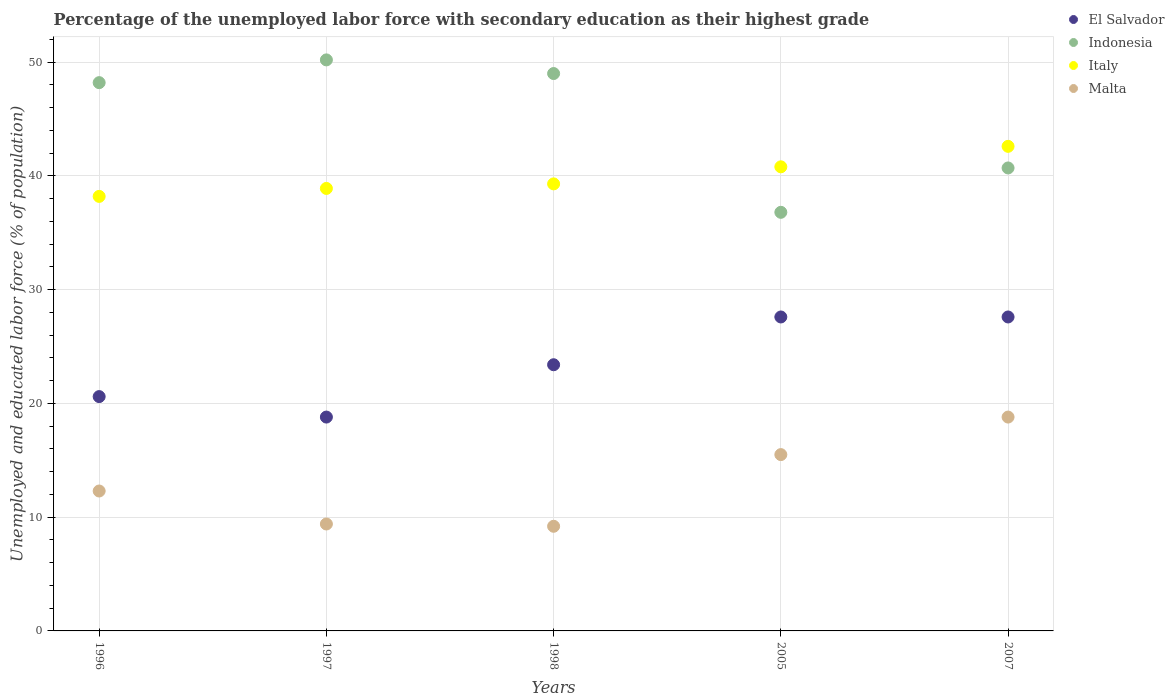How many different coloured dotlines are there?
Keep it short and to the point. 4. What is the percentage of the unemployed labor force with secondary education in Malta in 1998?
Offer a very short reply. 9.2. Across all years, what is the maximum percentage of the unemployed labor force with secondary education in Italy?
Make the answer very short. 42.6. Across all years, what is the minimum percentage of the unemployed labor force with secondary education in Indonesia?
Offer a very short reply. 36.8. In which year was the percentage of the unemployed labor force with secondary education in Malta maximum?
Give a very brief answer. 2007. What is the total percentage of the unemployed labor force with secondary education in El Salvador in the graph?
Offer a very short reply. 118. What is the difference between the percentage of the unemployed labor force with secondary education in Malta in 1996 and that in 1998?
Provide a short and direct response. 3.1. What is the difference between the percentage of the unemployed labor force with secondary education in El Salvador in 2005 and the percentage of the unemployed labor force with secondary education in Indonesia in 1996?
Keep it short and to the point. -20.6. What is the average percentage of the unemployed labor force with secondary education in Malta per year?
Keep it short and to the point. 13.04. In the year 2007, what is the difference between the percentage of the unemployed labor force with secondary education in Malta and percentage of the unemployed labor force with secondary education in El Salvador?
Your response must be concise. -8.8. What is the ratio of the percentage of the unemployed labor force with secondary education in Italy in 1998 to that in 2005?
Make the answer very short. 0.96. Is the percentage of the unemployed labor force with secondary education in El Salvador in 1997 less than that in 1998?
Offer a terse response. Yes. What is the difference between the highest and the second highest percentage of the unemployed labor force with secondary education in Malta?
Your answer should be compact. 3.3. What is the difference between the highest and the lowest percentage of the unemployed labor force with secondary education in Indonesia?
Give a very brief answer. 13.4. Is it the case that in every year, the sum of the percentage of the unemployed labor force with secondary education in Indonesia and percentage of the unemployed labor force with secondary education in Malta  is greater than the percentage of the unemployed labor force with secondary education in El Salvador?
Ensure brevity in your answer.  Yes. Does the percentage of the unemployed labor force with secondary education in Malta monotonically increase over the years?
Provide a succinct answer. No. Is the percentage of the unemployed labor force with secondary education in El Salvador strictly greater than the percentage of the unemployed labor force with secondary education in Indonesia over the years?
Give a very brief answer. No. Are the values on the major ticks of Y-axis written in scientific E-notation?
Offer a very short reply. No. What is the title of the graph?
Your answer should be compact. Percentage of the unemployed labor force with secondary education as their highest grade. What is the label or title of the X-axis?
Make the answer very short. Years. What is the label or title of the Y-axis?
Your answer should be compact. Unemployed and educated labor force (% of population). What is the Unemployed and educated labor force (% of population) of El Salvador in 1996?
Provide a short and direct response. 20.6. What is the Unemployed and educated labor force (% of population) in Indonesia in 1996?
Your answer should be very brief. 48.2. What is the Unemployed and educated labor force (% of population) in Italy in 1996?
Your answer should be compact. 38.2. What is the Unemployed and educated labor force (% of population) of Malta in 1996?
Offer a terse response. 12.3. What is the Unemployed and educated labor force (% of population) of El Salvador in 1997?
Provide a succinct answer. 18.8. What is the Unemployed and educated labor force (% of population) in Indonesia in 1997?
Your response must be concise. 50.2. What is the Unemployed and educated labor force (% of population) of Italy in 1997?
Provide a short and direct response. 38.9. What is the Unemployed and educated labor force (% of population) in Malta in 1997?
Your answer should be compact. 9.4. What is the Unemployed and educated labor force (% of population) in El Salvador in 1998?
Your answer should be compact. 23.4. What is the Unemployed and educated labor force (% of population) of Indonesia in 1998?
Your answer should be compact. 49. What is the Unemployed and educated labor force (% of population) of Italy in 1998?
Your response must be concise. 39.3. What is the Unemployed and educated labor force (% of population) in Malta in 1998?
Offer a terse response. 9.2. What is the Unemployed and educated labor force (% of population) of El Salvador in 2005?
Provide a short and direct response. 27.6. What is the Unemployed and educated labor force (% of population) of Indonesia in 2005?
Ensure brevity in your answer.  36.8. What is the Unemployed and educated labor force (% of population) of Italy in 2005?
Give a very brief answer. 40.8. What is the Unemployed and educated labor force (% of population) of El Salvador in 2007?
Offer a terse response. 27.6. What is the Unemployed and educated labor force (% of population) of Indonesia in 2007?
Keep it short and to the point. 40.7. What is the Unemployed and educated labor force (% of population) of Italy in 2007?
Keep it short and to the point. 42.6. What is the Unemployed and educated labor force (% of population) in Malta in 2007?
Offer a terse response. 18.8. Across all years, what is the maximum Unemployed and educated labor force (% of population) of El Salvador?
Provide a short and direct response. 27.6. Across all years, what is the maximum Unemployed and educated labor force (% of population) in Indonesia?
Your answer should be very brief. 50.2. Across all years, what is the maximum Unemployed and educated labor force (% of population) in Italy?
Keep it short and to the point. 42.6. Across all years, what is the maximum Unemployed and educated labor force (% of population) of Malta?
Ensure brevity in your answer.  18.8. Across all years, what is the minimum Unemployed and educated labor force (% of population) in El Salvador?
Provide a succinct answer. 18.8. Across all years, what is the minimum Unemployed and educated labor force (% of population) in Indonesia?
Provide a short and direct response. 36.8. Across all years, what is the minimum Unemployed and educated labor force (% of population) of Italy?
Offer a very short reply. 38.2. Across all years, what is the minimum Unemployed and educated labor force (% of population) of Malta?
Provide a succinct answer. 9.2. What is the total Unemployed and educated labor force (% of population) of El Salvador in the graph?
Your response must be concise. 118. What is the total Unemployed and educated labor force (% of population) in Indonesia in the graph?
Your response must be concise. 224.9. What is the total Unemployed and educated labor force (% of population) in Italy in the graph?
Keep it short and to the point. 199.8. What is the total Unemployed and educated labor force (% of population) of Malta in the graph?
Your answer should be very brief. 65.2. What is the difference between the Unemployed and educated labor force (% of population) in El Salvador in 1996 and that in 1997?
Give a very brief answer. 1.8. What is the difference between the Unemployed and educated labor force (% of population) of Indonesia in 1996 and that in 1997?
Make the answer very short. -2. What is the difference between the Unemployed and educated labor force (% of population) in Italy in 1996 and that in 1997?
Keep it short and to the point. -0.7. What is the difference between the Unemployed and educated labor force (% of population) in Italy in 1996 and that in 1998?
Keep it short and to the point. -1.1. What is the difference between the Unemployed and educated labor force (% of population) of El Salvador in 1996 and that in 2005?
Make the answer very short. -7. What is the difference between the Unemployed and educated labor force (% of population) of Malta in 1996 and that in 2005?
Your response must be concise. -3.2. What is the difference between the Unemployed and educated labor force (% of population) in El Salvador in 1996 and that in 2007?
Your answer should be compact. -7. What is the difference between the Unemployed and educated labor force (% of population) of Malta in 1996 and that in 2007?
Ensure brevity in your answer.  -6.5. What is the difference between the Unemployed and educated labor force (% of population) of Indonesia in 1997 and that in 1998?
Make the answer very short. 1.2. What is the difference between the Unemployed and educated labor force (% of population) of Indonesia in 1997 and that in 2005?
Offer a terse response. 13.4. What is the difference between the Unemployed and educated labor force (% of population) of Indonesia in 1997 and that in 2007?
Keep it short and to the point. 9.5. What is the difference between the Unemployed and educated labor force (% of population) of Italy in 1997 and that in 2007?
Your response must be concise. -3.7. What is the difference between the Unemployed and educated labor force (% of population) of Malta in 1997 and that in 2007?
Your response must be concise. -9.4. What is the difference between the Unemployed and educated labor force (% of population) in El Salvador in 1998 and that in 2005?
Your answer should be compact. -4.2. What is the difference between the Unemployed and educated labor force (% of population) of Indonesia in 1998 and that in 2005?
Offer a very short reply. 12.2. What is the difference between the Unemployed and educated labor force (% of population) of Italy in 1998 and that in 2005?
Your response must be concise. -1.5. What is the difference between the Unemployed and educated labor force (% of population) in El Salvador in 2005 and that in 2007?
Your response must be concise. 0. What is the difference between the Unemployed and educated labor force (% of population) of Indonesia in 2005 and that in 2007?
Offer a terse response. -3.9. What is the difference between the Unemployed and educated labor force (% of population) of Italy in 2005 and that in 2007?
Ensure brevity in your answer.  -1.8. What is the difference between the Unemployed and educated labor force (% of population) in Malta in 2005 and that in 2007?
Keep it short and to the point. -3.3. What is the difference between the Unemployed and educated labor force (% of population) of El Salvador in 1996 and the Unemployed and educated labor force (% of population) of Indonesia in 1997?
Provide a succinct answer. -29.6. What is the difference between the Unemployed and educated labor force (% of population) in El Salvador in 1996 and the Unemployed and educated labor force (% of population) in Italy in 1997?
Your response must be concise. -18.3. What is the difference between the Unemployed and educated labor force (% of population) of Indonesia in 1996 and the Unemployed and educated labor force (% of population) of Italy in 1997?
Keep it short and to the point. 9.3. What is the difference between the Unemployed and educated labor force (% of population) in Indonesia in 1996 and the Unemployed and educated labor force (% of population) in Malta in 1997?
Offer a very short reply. 38.8. What is the difference between the Unemployed and educated labor force (% of population) in Italy in 1996 and the Unemployed and educated labor force (% of population) in Malta in 1997?
Your response must be concise. 28.8. What is the difference between the Unemployed and educated labor force (% of population) of El Salvador in 1996 and the Unemployed and educated labor force (% of population) of Indonesia in 1998?
Provide a succinct answer. -28.4. What is the difference between the Unemployed and educated labor force (% of population) in El Salvador in 1996 and the Unemployed and educated labor force (% of population) in Italy in 1998?
Give a very brief answer. -18.7. What is the difference between the Unemployed and educated labor force (% of population) in El Salvador in 1996 and the Unemployed and educated labor force (% of population) in Malta in 1998?
Offer a terse response. 11.4. What is the difference between the Unemployed and educated labor force (% of population) of Indonesia in 1996 and the Unemployed and educated labor force (% of population) of Italy in 1998?
Make the answer very short. 8.9. What is the difference between the Unemployed and educated labor force (% of population) of Indonesia in 1996 and the Unemployed and educated labor force (% of population) of Malta in 1998?
Keep it short and to the point. 39. What is the difference between the Unemployed and educated labor force (% of population) of Italy in 1996 and the Unemployed and educated labor force (% of population) of Malta in 1998?
Your response must be concise. 29. What is the difference between the Unemployed and educated labor force (% of population) of El Salvador in 1996 and the Unemployed and educated labor force (% of population) of Indonesia in 2005?
Your answer should be compact. -16.2. What is the difference between the Unemployed and educated labor force (% of population) in El Salvador in 1996 and the Unemployed and educated labor force (% of population) in Italy in 2005?
Provide a succinct answer. -20.2. What is the difference between the Unemployed and educated labor force (% of population) of El Salvador in 1996 and the Unemployed and educated labor force (% of population) of Malta in 2005?
Offer a very short reply. 5.1. What is the difference between the Unemployed and educated labor force (% of population) of Indonesia in 1996 and the Unemployed and educated labor force (% of population) of Italy in 2005?
Provide a succinct answer. 7.4. What is the difference between the Unemployed and educated labor force (% of population) of Indonesia in 1996 and the Unemployed and educated labor force (% of population) of Malta in 2005?
Keep it short and to the point. 32.7. What is the difference between the Unemployed and educated labor force (% of population) of Italy in 1996 and the Unemployed and educated labor force (% of population) of Malta in 2005?
Your answer should be very brief. 22.7. What is the difference between the Unemployed and educated labor force (% of population) in El Salvador in 1996 and the Unemployed and educated labor force (% of population) in Indonesia in 2007?
Provide a succinct answer. -20.1. What is the difference between the Unemployed and educated labor force (% of population) of El Salvador in 1996 and the Unemployed and educated labor force (% of population) of Italy in 2007?
Ensure brevity in your answer.  -22. What is the difference between the Unemployed and educated labor force (% of population) of El Salvador in 1996 and the Unemployed and educated labor force (% of population) of Malta in 2007?
Keep it short and to the point. 1.8. What is the difference between the Unemployed and educated labor force (% of population) in Indonesia in 1996 and the Unemployed and educated labor force (% of population) in Italy in 2007?
Your answer should be compact. 5.6. What is the difference between the Unemployed and educated labor force (% of population) of Indonesia in 1996 and the Unemployed and educated labor force (% of population) of Malta in 2007?
Your response must be concise. 29.4. What is the difference between the Unemployed and educated labor force (% of population) of Italy in 1996 and the Unemployed and educated labor force (% of population) of Malta in 2007?
Offer a terse response. 19.4. What is the difference between the Unemployed and educated labor force (% of population) of El Salvador in 1997 and the Unemployed and educated labor force (% of population) of Indonesia in 1998?
Give a very brief answer. -30.2. What is the difference between the Unemployed and educated labor force (% of population) of El Salvador in 1997 and the Unemployed and educated labor force (% of population) of Italy in 1998?
Offer a very short reply. -20.5. What is the difference between the Unemployed and educated labor force (% of population) in Italy in 1997 and the Unemployed and educated labor force (% of population) in Malta in 1998?
Make the answer very short. 29.7. What is the difference between the Unemployed and educated labor force (% of population) of El Salvador in 1997 and the Unemployed and educated labor force (% of population) of Italy in 2005?
Your answer should be very brief. -22. What is the difference between the Unemployed and educated labor force (% of population) of Indonesia in 1997 and the Unemployed and educated labor force (% of population) of Italy in 2005?
Provide a succinct answer. 9.4. What is the difference between the Unemployed and educated labor force (% of population) of Indonesia in 1997 and the Unemployed and educated labor force (% of population) of Malta in 2005?
Give a very brief answer. 34.7. What is the difference between the Unemployed and educated labor force (% of population) in Italy in 1997 and the Unemployed and educated labor force (% of population) in Malta in 2005?
Your response must be concise. 23.4. What is the difference between the Unemployed and educated labor force (% of population) in El Salvador in 1997 and the Unemployed and educated labor force (% of population) in Indonesia in 2007?
Provide a succinct answer. -21.9. What is the difference between the Unemployed and educated labor force (% of population) of El Salvador in 1997 and the Unemployed and educated labor force (% of population) of Italy in 2007?
Provide a succinct answer. -23.8. What is the difference between the Unemployed and educated labor force (% of population) of Indonesia in 1997 and the Unemployed and educated labor force (% of population) of Italy in 2007?
Your answer should be compact. 7.6. What is the difference between the Unemployed and educated labor force (% of population) of Indonesia in 1997 and the Unemployed and educated labor force (% of population) of Malta in 2007?
Offer a terse response. 31.4. What is the difference between the Unemployed and educated labor force (% of population) in Italy in 1997 and the Unemployed and educated labor force (% of population) in Malta in 2007?
Keep it short and to the point. 20.1. What is the difference between the Unemployed and educated labor force (% of population) of El Salvador in 1998 and the Unemployed and educated labor force (% of population) of Indonesia in 2005?
Give a very brief answer. -13.4. What is the difference between the Unemployed and educated labor force (% of population) of El Salvador in 1998 and the Unemployed and educated labor force (% of population) of Italy in 2005?
Make the answer very short. -17.4. What is the difference between the Unemployed and educated labor force (% of population) in Indonesia in 1998 and the Unemployed and educated labor force (% of population) in Italy in 2005?
Make the answer very short. 8.2. What is the difference between the Unemployed and educated labor force (% of population) in Indonesia in 1998 and the Unemployed and educated labor force (% of population) in Malta in 2005?
Offer a terse response. 33.5. What is the difference between the Unemployed and educated labor force (% of population) of Italy in 1998 and the Unemployed and educated labor force (% of population) of Malta in 2005?
Offer a terse response. 23.8. What is the difference between the Unemployed and educated labor force (% of population) in El Salvador in 1998 and the Unemployed and educated labor force (% of population) in Indonesia in 2007?
Your answer should be very brief. -17.3. What is the difference between the Unemployed and educated labor force (% of population) of El Salvador in 1998 and the Unemployed and educated labor force (% of population) of Italy in 2007?
Give a very brief answer. -19.2. What is the difference between the Unemployed and educated labor force (% of population) in Indonesia in 1998 and the Unemployed and educated labor force (% of population) in Italy in 2007?
Offer a very short reply. 6.4. What is the difference between the Unemployed and educated labor force (% of population) of Indonesia in 1998 and the Unemployed and educated labor force (% of population) of Malta in 2007?
Ensure brevity in your answer.  30.2. What is the difference between the Unemployed and educated labor force (% of population) in Indonesia in 2005 and the Unemployed and educated labor force (% of population) in Italy in 2007?
Offer a terse response. -5.8. What is the difference between the Unemployed and educated labor force (% of population) of Italy in 2005 and the Unemployed and educated labor force (% of population) of Malta in 2007?
Ensure brevity in your answer.  22. What is the average Unemployed and educated labor force (% of population) in El Salvador per year?
Your answer should be very brief. 23.6. What is the average Unemployed and educated labor force (% of population) in Indonesia per year?
Your answer should be very brief. 44.98. What is the average Unemployed and educated labor force (% of population) of Italy per year?
Your answer should be compact. 39.96. What is the average Unemployed and educated labor force (% of population) in Malta per year?
Offer a very short reply. 13.04. In the year 1996, what is the difference between the Unemployed and educated labor force (% of population) of El Salvador and Unemployed and educated labor force (% of population) of Indonesia?
Keep it short and to the point. -27.6. In the year 1996, what is the difference between the Unemployed and educated labor force (% of population) of El Salvador and Unemployed and educated labor force (% of population) of Italy?
Make the answer very short. -17.6. In the year 1996, what is the difference between the Unemployed and educated labor force (% of population) of Indonesia and Unemployed and educated labor force (% of population) of Italy?
Keep it short and to the point. 10. In the year 1996, what is the difference between the Unemployed and educated labor force (% of population) of Indonesia and Unemployed and educated labor force (% of population) of Malta?
Your answer should be very brief. 35.9. In the year 1996, what is the difference between the Unemployed and educated labor force (% of population) of Italy and Unemployed and educated labor force (% of population) of Malta?
Provide a succinct answer. 25.9. In the year 1997, what is the difference between the Unemployed and educated labor force (% of population) of El Salvador and Unemployed and educated labor force (% of population) of Indonesia?
Provide a short and direct response. -31.4. In the year 1997, what is the difference between the Unemployed and educated labor force (% of population) of El Salvador and Unemployed and educated labor force (% of population) of Italy?
Offer a very short reply. -20.1. In the year 1997, what is the difference between the Unemployed and educated labor force (% of population) of Indonesia and Unemployed and educated labor force (% of population) of Italy?
Give a very brief answer. 11.3. In the year 1997, what is the difference between the Unemployed and educated labor force (% of population) of Indonesia and Unemployed and educated labor force (% of population) of Malta?
Make the answer very short. 40.8. In the year 1997, what is the difference between the Unemployed and educated labor force (% of population) of Italy and Unemployed and educated labor force (% of population) of Malta?
Offer a terse response. 29.5. In the year 1998, what is the difference between the Unemployed and educated labor force (% of population) in El Salvador and Unemployed and educated labor force (% of population) in Indonesia?
Offer a very short reply. -25.6. In the year 1998, what is the difference between the Unemployed and educated labor force (% of population) in El Salvador and Unemployed and educated labor force (% of population) in Italy?
Provide a succinct answer. -15.9. In the year 1998, what is the difference between the Unemployed and educated labor force (% of population) of El Salvador and Unemployed and educated labor force (% of population) of Malta?
Ensure brevity in your answer.  14.2. In the year 1998, what is the difference between the Unemployed and educated labor force (% of population) in Indonesia and Unemployed and educated labor force (% of population) in Malta?
Provide a succinct answer. 39.8. In the year 1998, what is the difference between the Unemployed and educated labor force (% of population) in Italy and Unemployed and educated labor force (% of population) in Malta?
Give a very brief answer. 30.1. In the year 2005, what is the difference between the Unemployed and educated labor force (% of population) in El Salvador and Unemployed and educated labor force (% of population) in Italy?
Ensure brevity in your answer.  -13.2. In the year 2005, what is the difference between the Unemployed and educated labor force (% of population) of El Salvador and Unemployed and educated labor force (% of population) of Malta?
Keep it short and to the point. 12.1. In the year 2005, what is the difference between the Unemployed and educated labor force (% of population) of Indonesia and Unemployed and educated labor force (% of population) of Italy?
Your response must be concise. -4. In the year 2005, what is the difference between the Unemployed and educated labor force (% of population) in Indonesia and Unemployed and educated labor force (% of population) in Malta?
Keep it short and to the point. 21.3. In the year 2005, what is the difference between the Unemployed and educated labor force (% of population) in Italy and Unemployed and educated labor force (% of population) in Malta?
Keep it short and to the point. 25.3. In the year 2007, what is the difference between the Unemployed and educated labor force (% of population) in El Salvador and Unemployed and educated labor force (% of population) in Malta?
Provide a short and direct response. 8.8. In the year 2007, what is the difference between the Unemployed and educated labor force (% of population) in Indonesia and Unemployed and educated labor force (% of population) in Malta?
Offer a terse response. 21.9. In the year 2007, what is the difference between the Unemployed and educated labor force (% of population) in Italy and Unemployed and educated labor force (% of population) in Malta?
Keep it short and to the point. 23.8. What is the ratio of the Unemployed and educated labor force (% of population) of El Salvador in 1996 to that in 1997?
Provide a short and direct response. 1.1. What is the ratio of the Unemployed and educated labor force (% of population) of Indonesia in 1996 to that in 1997?
Give a very brief answer. 0.96. What is the ratio of the Unemployed and educated labor force (% of population) of Italy in 1996 to that in 1997?
Provide a short and direct response. 0.98. What is the ratio of the Unemployed and educated labor force (% of population) of Malta in 1996 to that in 1997?
Ensure brevity in your answer.  1.31. What is the ratio of the Unemployed and educated labor force (% of population) in El Salvador in 1996 to that in 1998?
Offer a very short reply. 0.88. What is the ratio of the Unemployed and educated labor force (% of population) of Indonesia in 1996 to that in 1998?
Keep it short and to the point. 0.98. What is the ratio of the Unemployed and educated labor force (% of population) in Malta in 1996 to that in 1998?
Your answer should be very brief. 1.34. What is the ratio of the Unemployed and educated labor force (% of population) of El Salvador in 1996 to that in 2005?
Your answer should be compact. 0.75. What is the ratio of the Unemployed and educated labor force (% of population) of Indonesia in 1996 to that in 2005?
Your answer should be very brief. 1.31. What is the ratio of the Unemployed and educated labor force (% of population) of Italy in 1996 to that in 2005?
Ensure brevity in your answer.  0.94. What is the ratio of the Unemployed and educated labor force (% of population) in Malta in 1996 to that in 2005?
Provide a short and direct response. 0.79. What is the ratio of the Unemployed and educated labor force (% of population) of El Salvador in 1996 to that in 2007?
Offer a terse response. 0.75. What is the ratio of the Unemployed and educated labor force (% of population) of Indonesia in 1996 to that in 2007?
Make the answer very short. 1.18. What is the ratio of the Unemployed and educated labor force (% of population) of Italy in 1996 to that in 2007?
Offer a very short reply. 0.9. What is the ratio of the Unemployed and educated labor force (% of population) of Malta in 1996 to that in 2007?
Give a very brief answer. 0.65. What is the ratio of the Unemployed and educated labor force (% of population) in El Salvador in 1997 to that in 1998?
Give a very brief answer. 0.8. What is the ratio of the Unemployed and educated labor force (% of population) in Indonesia in 1997 to that in 1998?
Provide a short and direct response. 1.02. What is the ratio of the Unemployed and educated labor force (% of population) in Malta in 1997 to that in 1998?
Ensure brevity in your answer.  1.02. What is the ratio of the Unemployed and educated labor force (% of population) in El Salvador in 1997 to that in 2005?
Keep it short and to the point. 0.68. What is the ratio of the Unemployed and educated labor force (% of population) of Indonesia in 1997 to that in 2005?
Make the answer very short. 1.36. What is the ratio of the Unemployed and educated labor force (% of population) of Italy in 1997 to that in 2005?
Your response must be concise. 0.95. What is the ratio of the Unemployed and educated labor force (% of population) in Malta in 1997 to that in 2005?
Provide a short and direct response. 0.61. What is the ratio of the Unemployed and educated labor force (% of population) in El Salvador in 1997 to that in 2007?
Offer a terse response. 0.68. What is the ratio of the Unemployed and educated labor force (% of population) of Indonesia in 1997 to that in 2007?
Your response must be concise. 1.23. What is the ratio of the Unemployed and educated labor force (% of population) in Italy in 1997 to that in 2007?
Keep it short and to the point. 0.91. What is the ratio of the Unemployed and educated labor force (% of population) of Malta in 1997 to that in 2007?
Offer a very short reply. 0.5. What is the ratio of the Unemployed and educated labor force (% of population) in El Salvador in 1998 to that in 2005?
Give a very brief answer. 0.85. What is the ratio of the Unemployed and educated labor force (% of population) of Indonesia in 1998 to that in 2005?
Your answer should be compact. 1.33. What is the ratio of the Unemployed and educated labor force (% of population) of Italy in 1998 to that in 2005?
Make the answer very short. 0.96. What is the ratio of the Unemployed and educated labor force (% of population) in Malta in 1998 to that in 2005?
Offer a very short reply. 0.59. What is the ratio of the Unemployed and educated labor force (% of population) in El Salvador in 1998 to that in 2007?
Keep it short and to the point. 0.85. What is the ratio of the Unemployed and educated labor force (% of population) of Indonesia in 1998 to that in 2007?
Give a very brief answer. 1.2. What is the ratio of the Unemployed and educated labor force (% of population) in Italy in 1998 to that in 2007?
Offer a terse response. 0.92. What is the ratio of the Unemployed and educated labor force (% of population) of Malta in 1998 to that in 2007?
Provide a short and direct response. 0.49. What is the ratio of the Unemployed and educated labor force (% of population) of El Salvador in 2005 to that in 2007?
Provide a succinct answer. 1. What is the ratio of the Unemployed and educated labor force (% of population) of Indonesia in 2005 to that in 2007?
Give a very brief answer. 0.9. What is the ratio of the Unemployed and educated labor force (% of population) in Italy in 2005 to that in 2007?
Your response must be concise. 0.96. What is the ratio of the Unemployed and educated labor force (% of population) in Malta in 2005 to that in 2007?
Give a very brief answer. 0.82. What is the difference between the highest and the second highest Unemployed and educated labor force (% of population) of Indonesia?
Ensure brevity in your answer.  1.2. What is the difference between the highest and the second highest Unemployed and educated labor force (% of population) in Italy?
Offer a very short reply. 1.8. What is the difference between the highest and the lowest Unemployed and educated labor force (% of population) in El Salvador?
Provide a succinct answer. 8.8. 